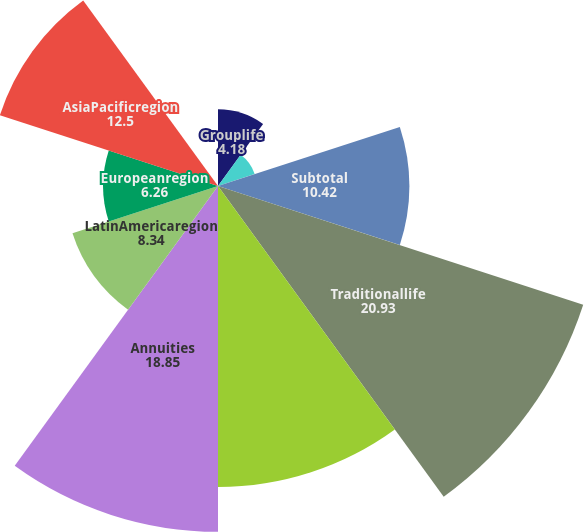<chart> <loc_0><loc_0><loc_500><loc_500><pie_chart><fcel>Grouplife<fcel>Retirement & savings<fcel>Subtotal<fcel>Traditionallife<fcel>Variable&universallife<fcel>Annuities<fcel>LatinAmericaregion<fcel>Europeanregion<fcel>AsiaPacificregion<fcel>Corporate&Other<nl><fcel>4.18%<fcel>2.1%<fcel>10.42%<fcel>20.93%<fcel>16.4%<fcel>18.85%<fcel>8.34%<fcel>6.26%<fcel>12.5%<fcel>0.02%<nl></chart> 